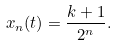Convert formula to latex. <formula><loc_0><loc_0><loc_500><loc_500>x _ { n } ( t ) = \frac { k + 1 } { 2 ^ { n } } .</formula> 